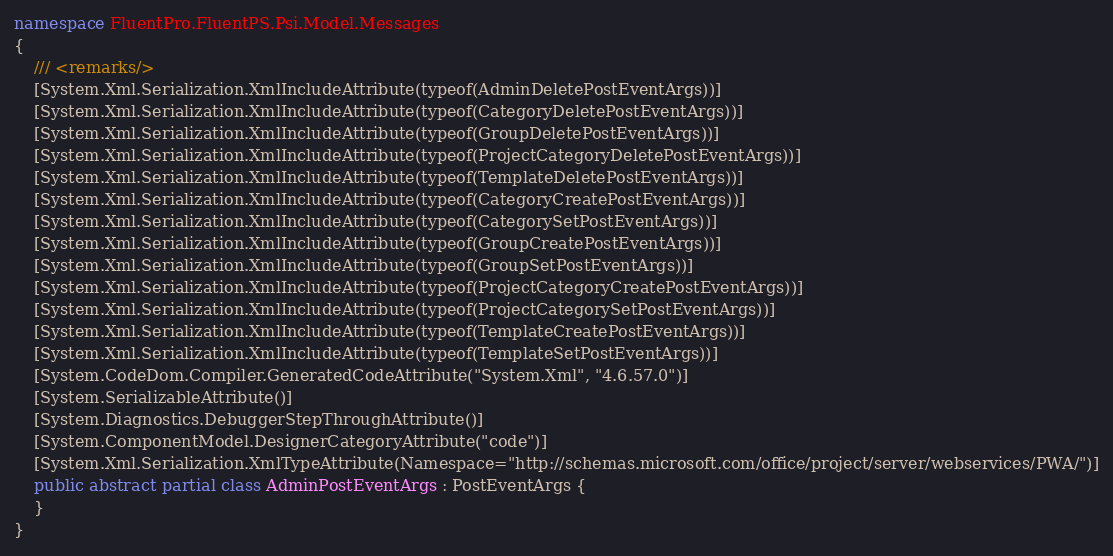Convert code to text. <code><loc_0><loc_0><loc_500><loc_500><_C#_>namespace FluentPro.FluentPS.Psi.Model.Messages
{
    /// <remarks/>
    [System.Xml.Serialization.XmlIncludeAttribute(typeof(AdminDeletePostEventArgs))]
    [System.Xml.Serialization.XmlIncludeAttribute(typeof(CategoryDeletePostEventArgs))]
    [System.Xml.Serialization.XmlIncludeAttribute(typeof(GroupDeletePostEventArgs))]
    [System.Xml.Serialization.XmlIncludeAttribute(typeof(ProjectCategoryDeletePostEventArgs))]
    [System.Xml.Serialization.XmlIncludeAttribute(typeof(TemplateDeletePostEventArgs))]
    [System.Xml.Serialization.XmlIncludeAttribute(typeof(CategoryCreatePostEventArgs))]
    [System.Xml.Serialization.XmlIncludeAttribute(typeof(CategorySetPostEventArgs))]
    [System.Xml.Serialization.XmlIncludeAttribute(typeof(GroupCreatePostEventArgs))]
    [System.Xml.Serialization.XmlIncludeAttribute(typeof(GroupSetPostEventArgs))]
    [System.Xml.Serialization.XmlIncludeAttribute(typeof(ProjectCategoryCreatePostEventArgs))]
    [System.Xml.Serialization.XmlIncludeAttribute(typeof(ProjectCategorySetPostEventArgs))]
    [System.Xml.Serialization.XmlIncludeAttribute(typeof(TemplateCreatePostEventArgs))]
    [System.Xml.Serialization.XmlIncludeAttribute(typeof(TemplateSetPostEventArgs))]
    [System.CodeDom.Compiler.GeneratedCodeAttribute("System.Xml", "4.6.57.0")]
    [System.SerializableAttribute()]
    [System.Diagnostics.DebuggerStepThroughAttribute()]
    [System.ComponentModel.DesignerCategoryAttribute("code")]
    [System.Xml.Serialization.XmlTypeAttribute(Namespace="http://schemas.microsoft.com/office/project/server/webservices/PWA/")]
    public abstract partial class AdminPostEventArgs : PostEventArgs {
    }
}</code> 